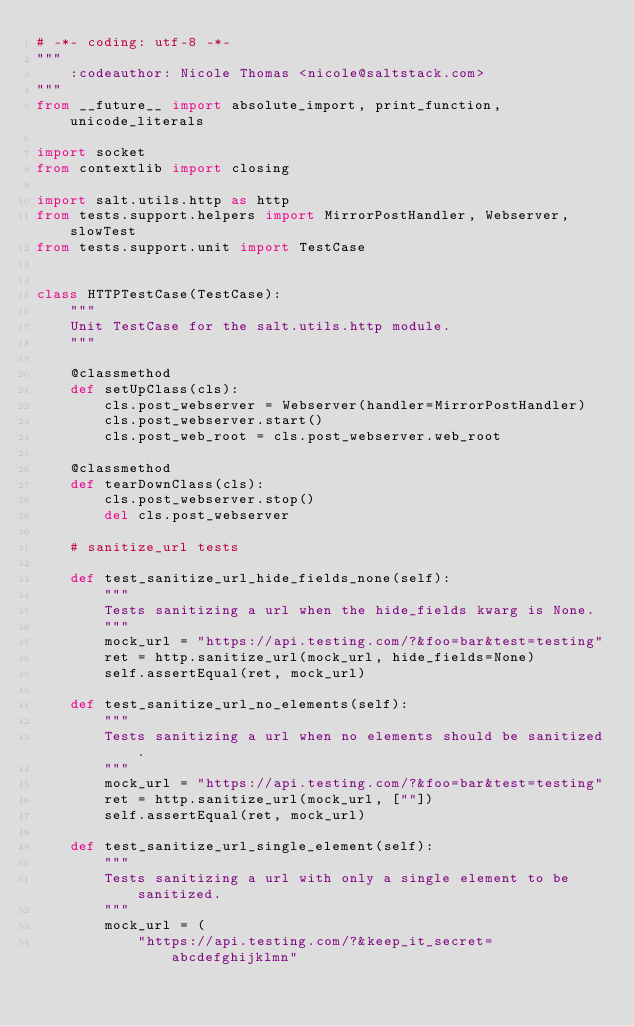<code> <loc_0><loc_0><loc_500><loc_500><_Python_># -*- coding: utf-8 -*-
"""
    :codeauthor: Nicole Thomas <nicole@saltstack.com>
"""
from __future__ import absolute_import, print_function, unicode_literals

import socket
from contextlib import closing

import salt.utils.http as http
from tests.support.helpers import MirrorPostHandler, Webserver, slowTest
from tests.support.unit import TestCase


class HTTPTestCase(TestCase):
    """
    Unit TestCase for the salt.utils.http module.
    """

    @classmethod
    def setUpClass(cls):
        cls.post_webserver = Webserver(handler=MirrorPostHandler)
        cls.post_webserver.start()
        cls.post_web_root = cls.post_webserver.web_root

    @classmethod
    def tearDownClass(cls):
        cls.post_webserver.stop()
        del cls.post_webserver

    # sanitize_url tests

    def test_sanitize_url_hide_fields_none(self):
        """
        Tests sanitizing a url when the hide_fields kwarg is None.
        """
        mock_url = "https://api.testing.com/?&foo=bar&test=testing"
        ret = http.sanitize_url(mock_url, hide_fields=None)
        self.assertEqual(ret, mock_url)

    def test_sanitize_url_no_elements(self):
        """
        Tests sanitizing a url when no elements should be sanitized.
        """
        mock_url = "https://api.testing.com/?&foo=bar&test=testing"
        ret = http.sanitize_url(mock_url, [""])
        self.assertEqual(ret, mock_url)

    def test_sanitize_url_single_element(self):
        """
        Tests sanitizing a url with only a single element to be sanitized.
        """
        mock_url = (
            "https://api.testing.com/?&keep_it_secret=abcdefghijklmn"</code> 